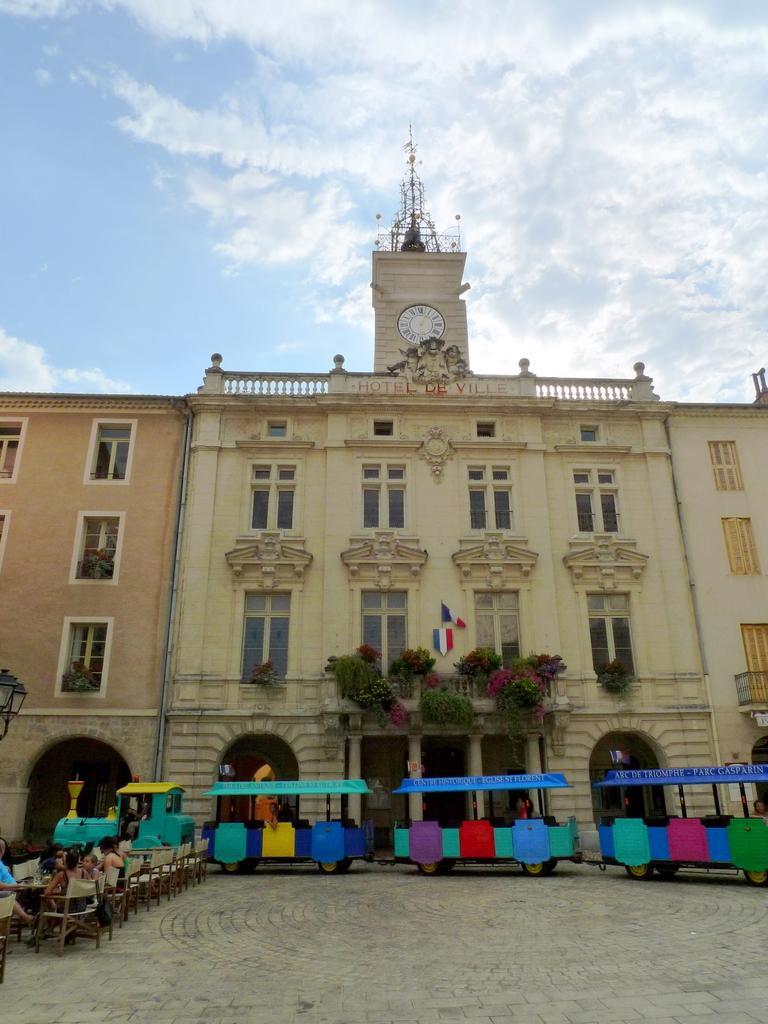How would you summarize this image in a sentence or two? In this image there is a building, on top of the building there is a clock and an antenna and there are flags and plants on the building, in front of the building there are chairs and tables, on the chairs there are a few kids seated, in front of the building there is a train, behind the train there is a lamp post, at the top of the image there are clouds in the sky. 